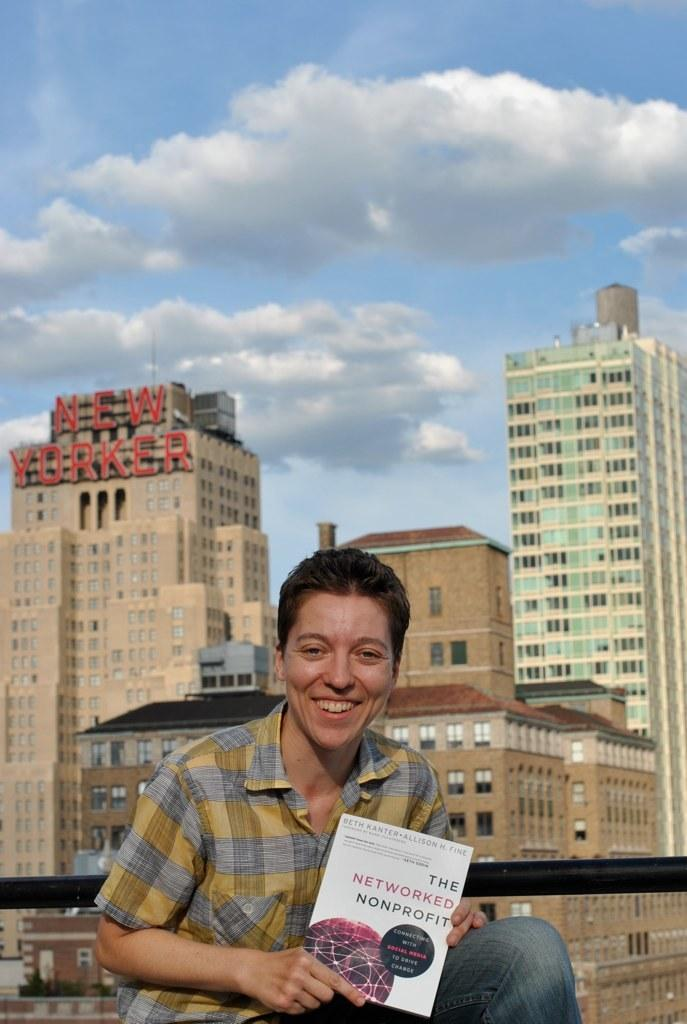Who is in the image? There is a person in the image. What is the person doing? The person is smiling. What is the person holding? The person is holding a book. What can be seen in the background of the image? There are buildings and the sky visible in the background of the image. What is the condition of the sky in the image? Clouds are present in the sky. What type of crown is the person wearing in the image? There is no crown present in the image; the person is holding a book and smiling. 